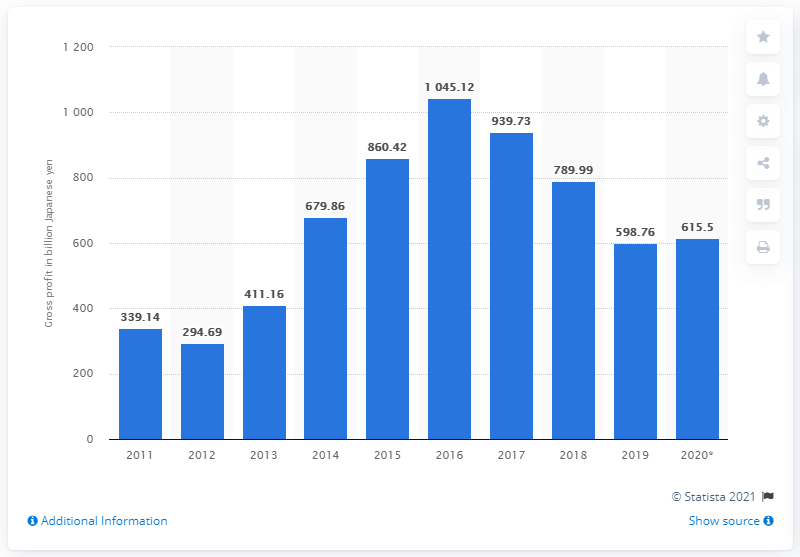List a handful of essential elements in this visual. The gross profit of Subaru Corporation in Japanese yen for the fiscal year ended March 31, 2020, was 615.5 million. 